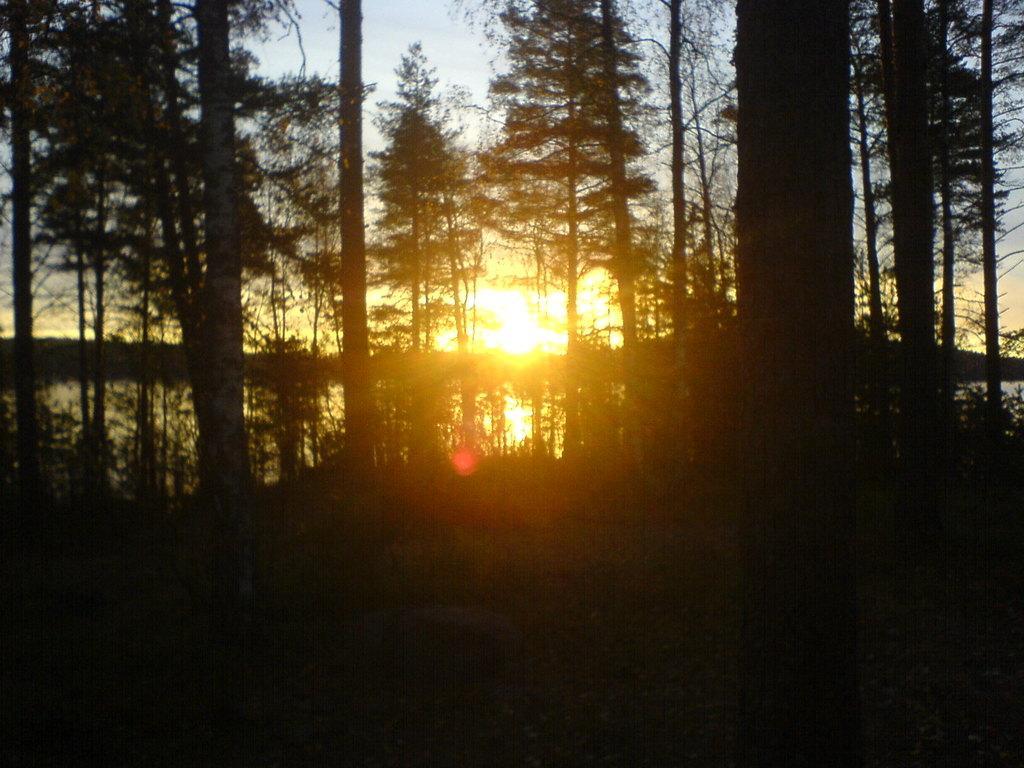In one or two sentences, can you explain what this image depicts? In this picture I can see trees, water and sunlight and I can see a cloudy sky. 